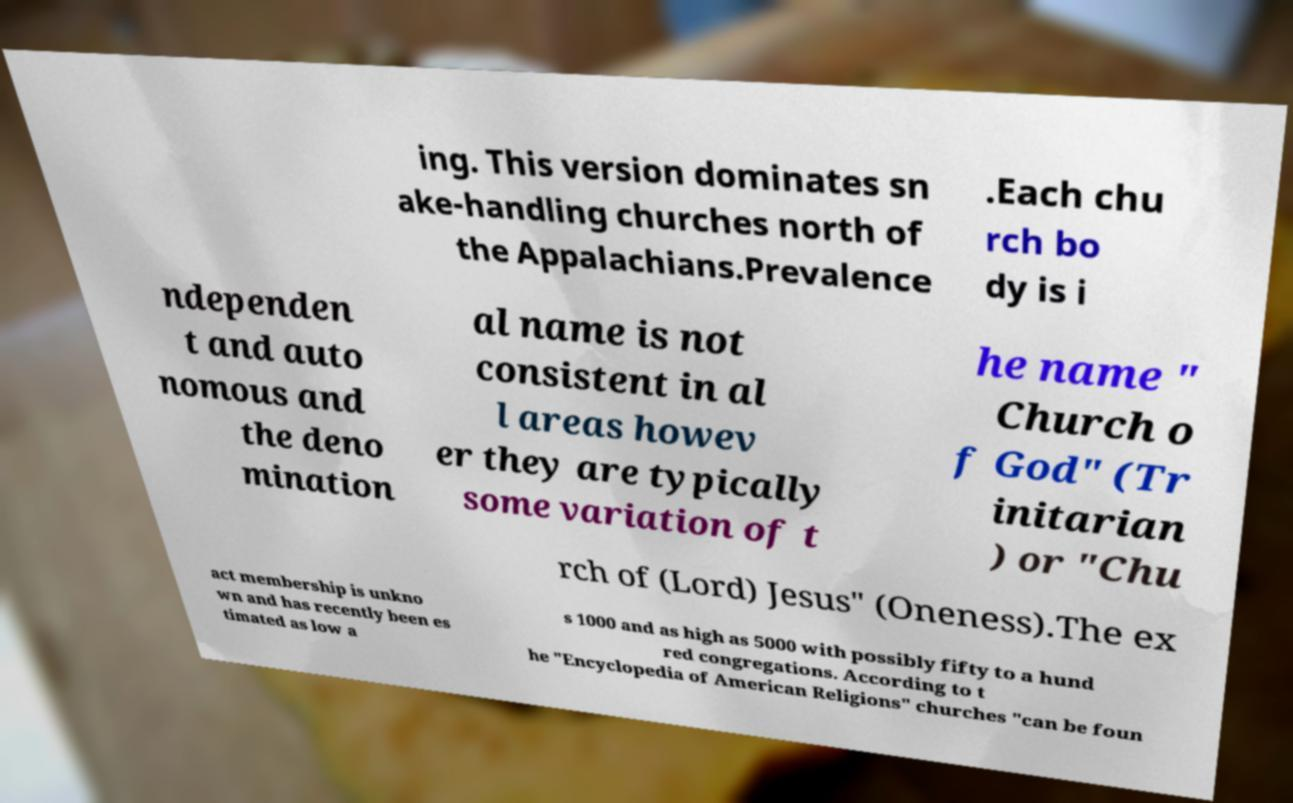There's text embedded in this image that I need extracted. Can you transcribe it verbatim? ing. This version dominates sn ake-handling churches north of the Appalachians.Prevalence .Each chu rch bo dy is i ndependen t and auto nomous and the deno mination al name is not consistent in al l areas howev er they are typically some variation of t he name " Church o f God" (Tr initarian ) or "Chu rch of (Lord) Jesus" (Oneness).The ex act membership is unkno wn and has recently been es timated as low a s 1000 and as high as 5000 with possibly fifty to a hund red congregations. According to t he "Encyclopedia of American Religions" churches "can be foun 